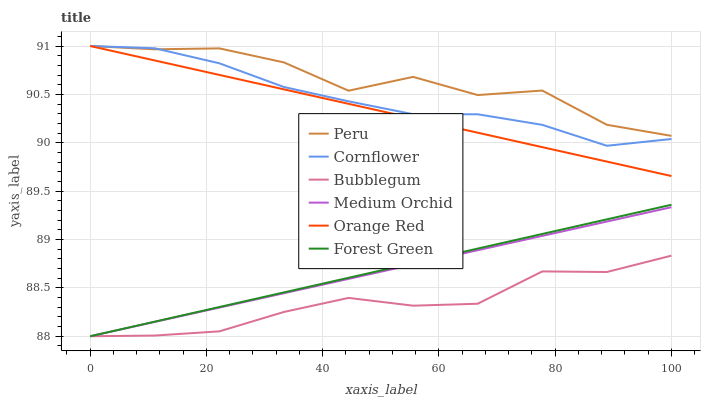Does Bubblegum have the minimum area under the curve?
Answer yes or no. Yes. Does Peru have the maximum area under the curve?
Answer yes or no. Yes. Does Medium Orchid have the minimum area under the curve?
Answer yes or no. No. Does Medium Orchid have the maximum area under the curve?
Answer yes or no. No. Is Forest Green the smoothest?
Answer yes or no. Yes. Is Peru the roughest?
Answer yes or no. Yes. Is Medium Orchid the smoothest?
Answer yes or no. No. Is Medium Orchid the roughest?
Answer yes or no. No. Does Medium Orchid have the lowest value?
Answer yes or no. Yes. Does Peru have the lowest value?
Answer yes or no. No. Does Orange Red have the highest value?
Answer yes or no. Yes. Does Medium Orchid have the highest value?
Answer yes or no. No. Is Bubblegum less than Orange Red?
Answer yes or no. Yes. Is Peru greater than Forest Green?
Answer yes or no. Yes. Does Cornflower intersect Orange Red?
Answer yes or no. Yes. Is Cornflower less than Orange Red?
Answer yes or no. No. Is Cornflower greater than Orange Red?
Answer yes or no. No. Does Bubblegum intersect Orange Red?
Answer yes or no. No. 